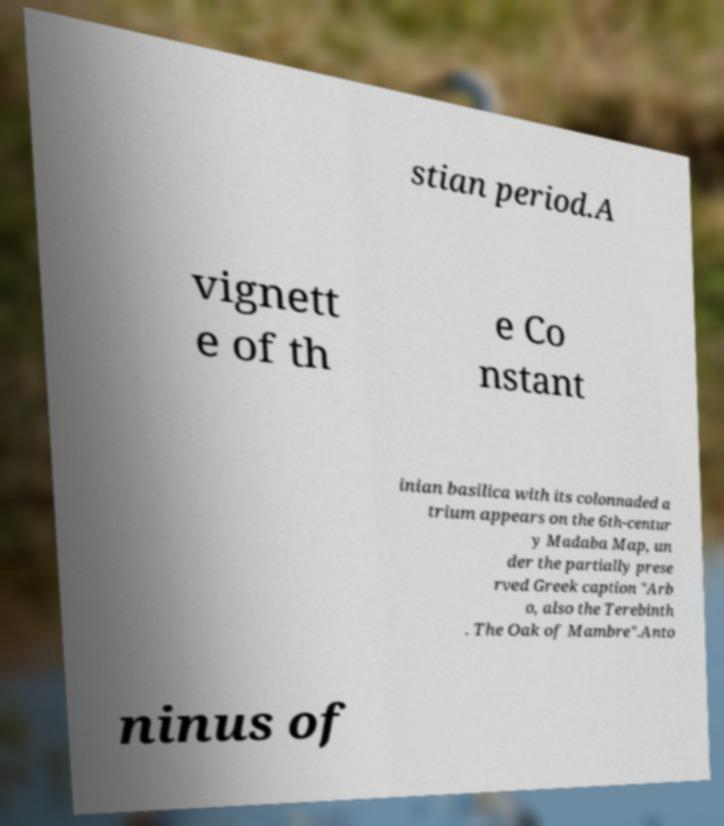What messages or text are displayed in this image? I need them in a readable, typed format. stian period.A vignett e of th e Co nstant inian basilica with its colonnaded a trium appears on the 6th-centur y Madaba Map, un der the partially prese rved Greek caption "Arb o, also the Terebinth . The Oak of Mambre".Anto ninus of 